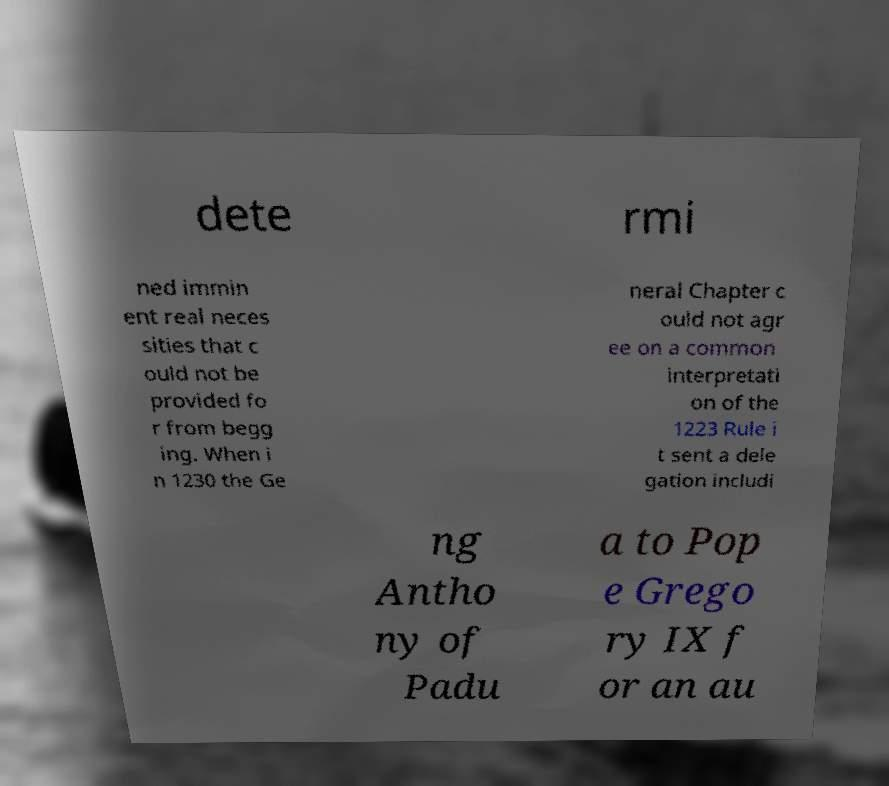Can you accurately transcribe the text from the provided image for me? dete rmi ned immin ent real neces sities that c ould not be provided fo r from begg ing. When i n 1230 the Ge neral Chapter c ould not agr ee on a common interpretati on of the 1223 Rule i t sent a dele gation includi ng Antho ny of Padu a to Pop e Grego ry IX f or an au 